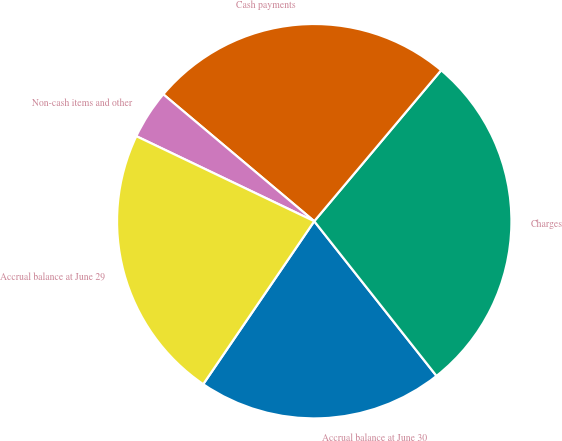Convert chart to OTSL. <chart><loc_0><loc_0><loc_500><loc_500><pie_chart><fcel>Accrual balance at June 30<fcel>Charges<fcel>Cash payments<fcel>Non-cash items and other<fcel>Accrual balance at June 29<nl><fcel>20.16%<fcel>28.23%<fcel>25.0%<fcel>4.03%<fcel>22.58%<nl></chart> 